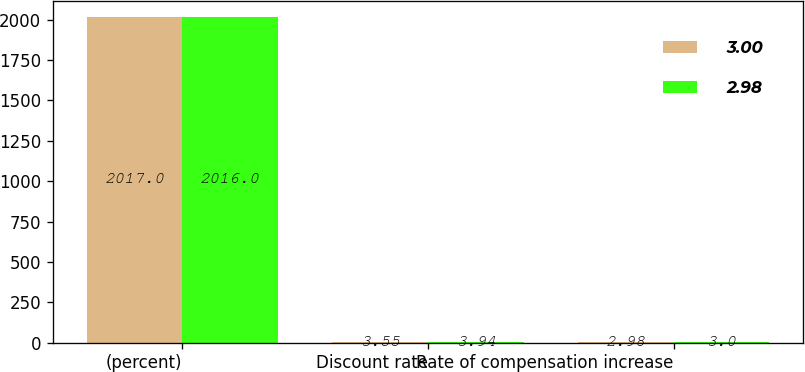Convert chart to OTSL. <chart><loc_0><loc_0><loc_500><loc_500><stacked_bar_chart><ecel><fcel>(percent)<fcel>Discount rate<fcel>Rate of compensation increase<nl><fcel>3<fcel>2017<fcel>3.55<fcel>2.98<nl><fcel>2.98<fcel>2016<fcel>3.94<fcel>3<nl></chart> 